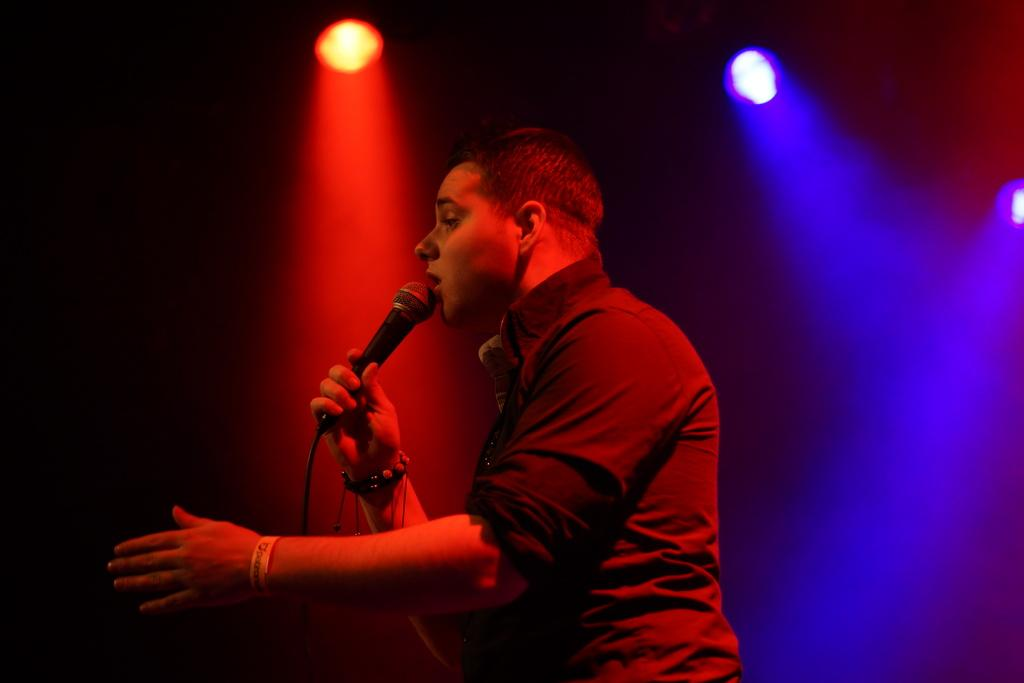What is the main subject of the picture? There is a person in the center of the picture. What is the person wearing? The person is wearing a black dress. What is the person holding? The person is holding a mic. What is the person doing in the image? The person is singing. What can be seen in the background of the image? There are focus lights in the background of the image. What type of apparatus is being used to control the plot of the song in the image? There is no apparatus present in the image, nor is there any indication of a plot being controlled. 